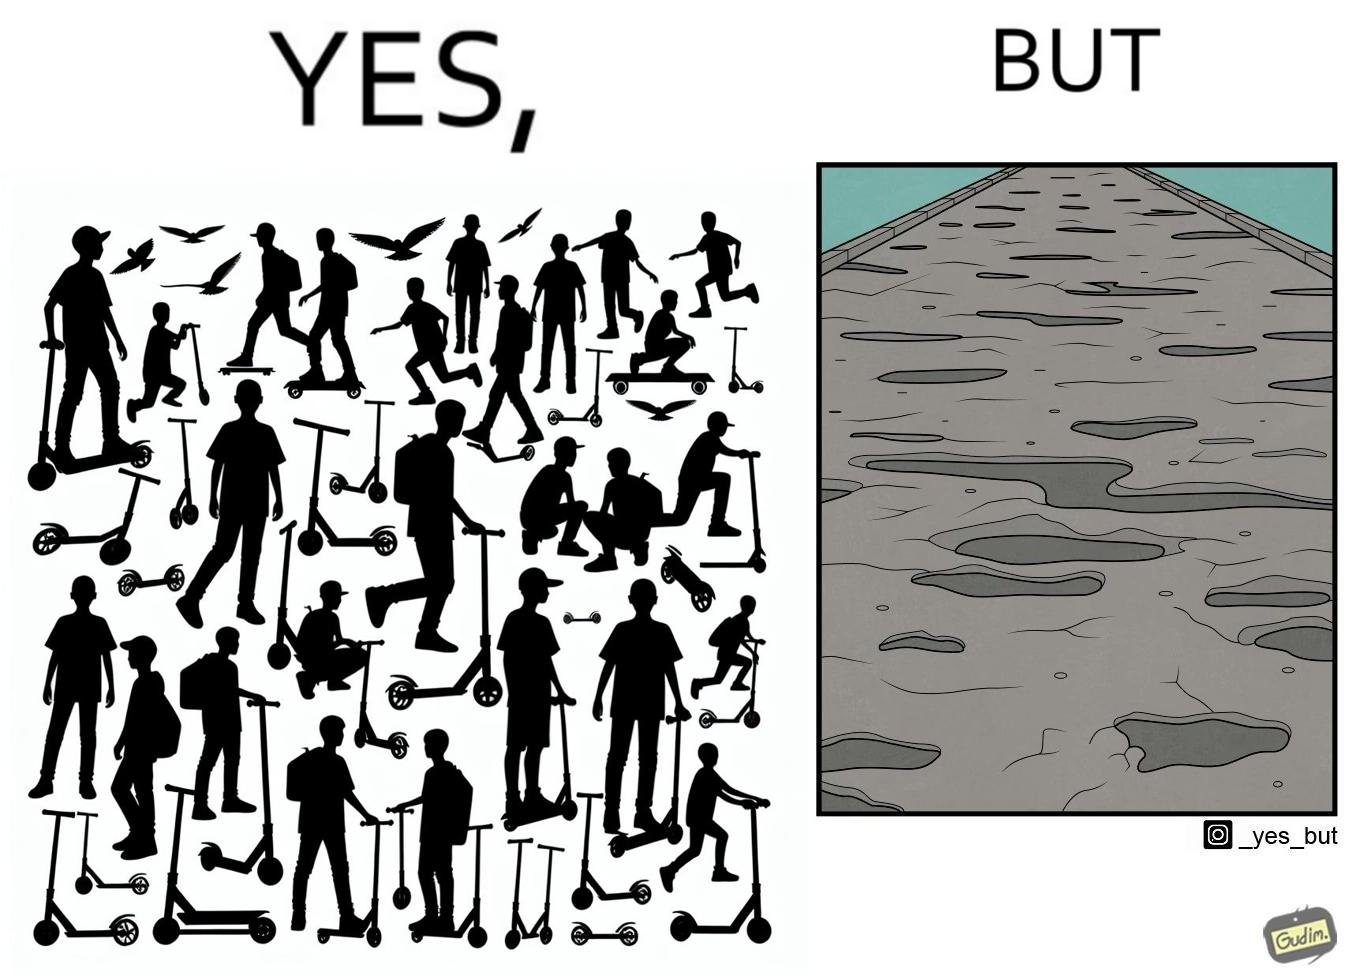Does this image contain satire or humor? Yes, this image is satirical. 